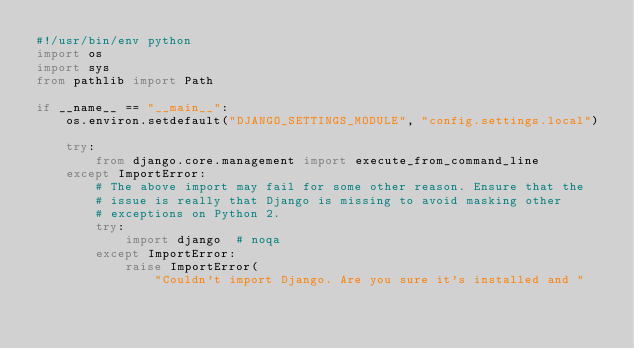<code> <loc_0><loc_0><loc_500><loc_500><_Python_>#!/usr/bin/env python
import os
import sys
from pathlib import Path

if __name__ == "__main__":
    os.environ.setdefault("DJANGO_SETTINGS_MODULE", "config.settings.local")

    try:
        from django.core.management import execute_from_command_line
    except ImportError:
        # The above import may fail for some other reason. Ensure that the
        # issue is really that Django is missing to avoid masking other
        # exceptions on Python 2.
        try:
            import django  # noqa
        except ImportError:
            raise ImportError(
                "Couldn't import Django. Are you sure it's installed and "</code> 